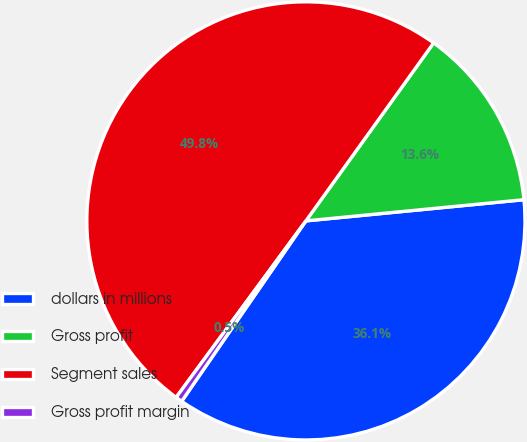Convert chart. <chart><loc_0><loc_0><loc_500><loc_500><pie_chart><fcel>dollars in millions<fcel>Gross profit<fcel>Segment sales<fcel>Gross profit margin<nl><fcel>36.14%<fcel>13.55%<fcel>49.82%<fcel>0.49%<nl></chart> 